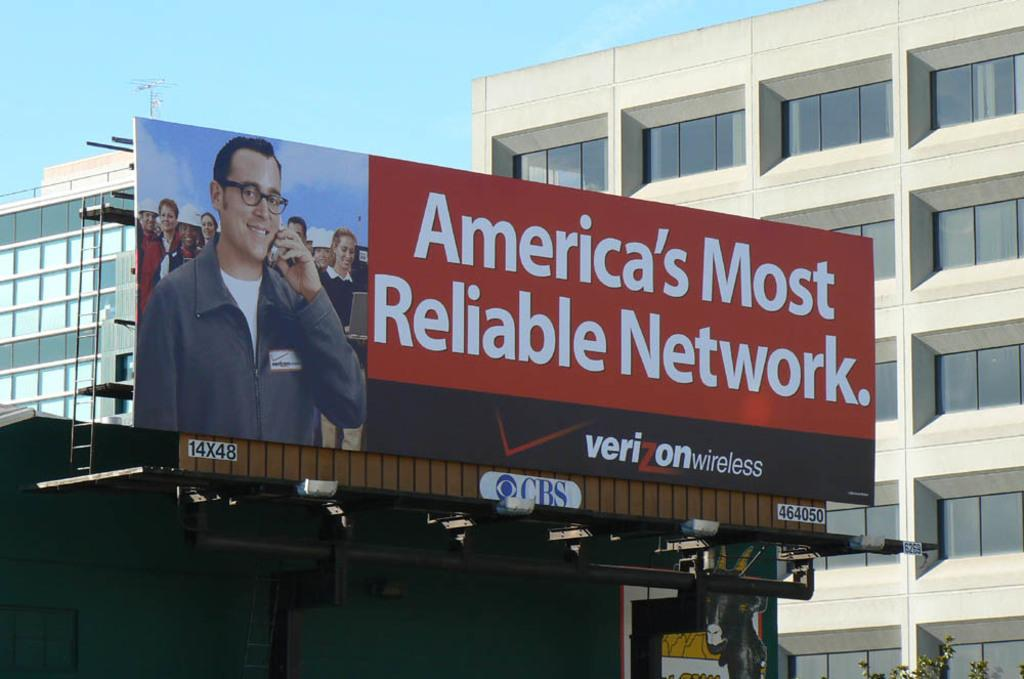<image>
Create a compact narrative representing the image presented. A billboard for Verizon wireless says America's Most Reliable Network. 